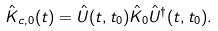<formula> <loc_0><loc_0><loc_500><loc_500>\hat { K } _ { c , 0 } ( t ) = \hat { U } ( t , t _ { 0 } ) \hat { K } _ { 0 } \hat { U } ^ { \dagger } ( t , t _ { 0 } ) .</formula> 